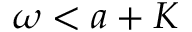<formula> <loc_0><loc_0><loc_500><loc_500>\omega < a + K</formula> 